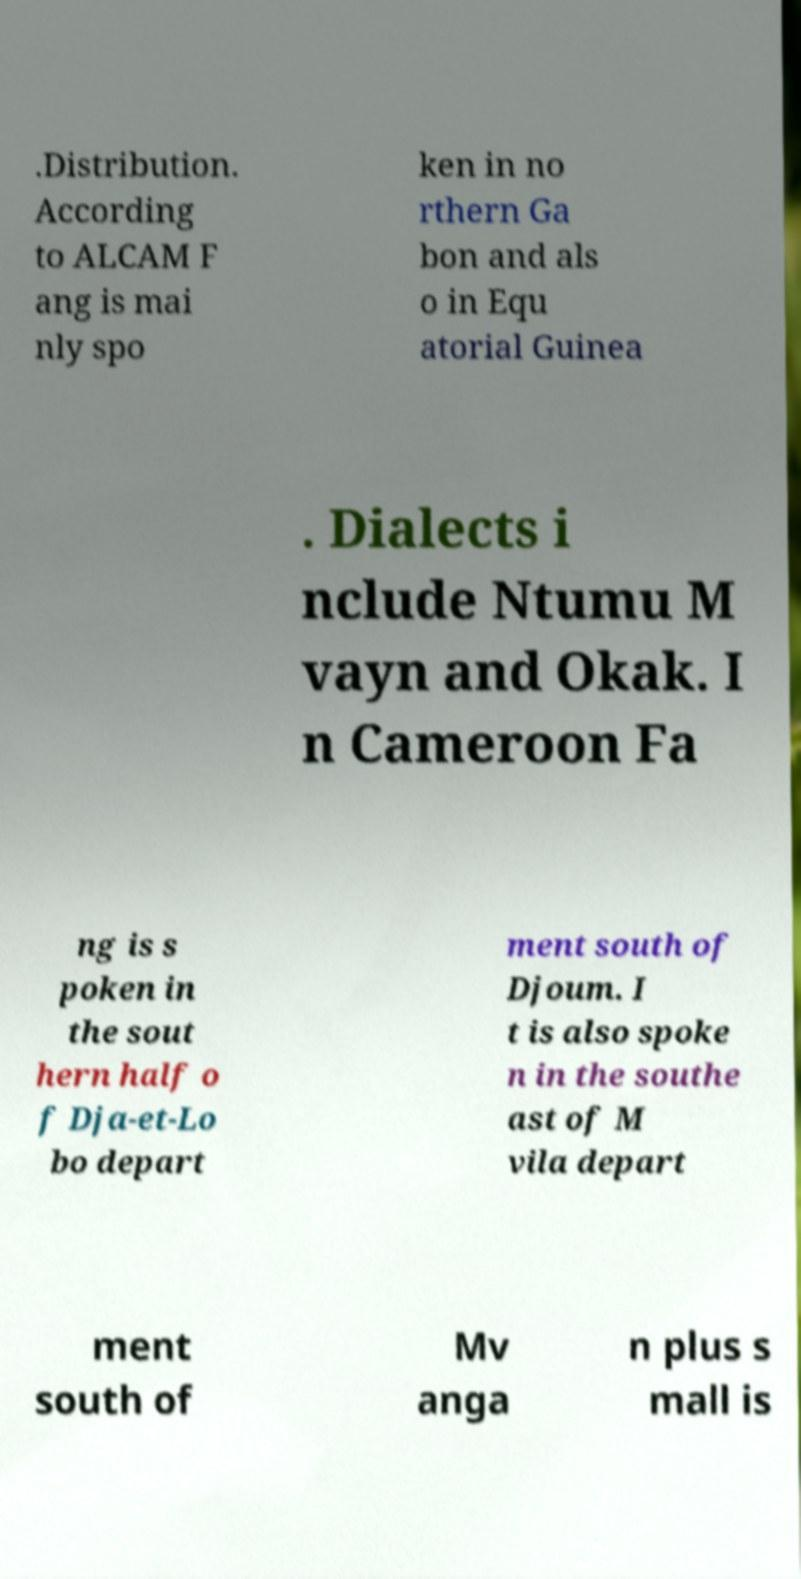Please read and relay the text visible in this image. What does it say? .Distribution. According to ALCAM F ang is mai nly spo ken in no rthern Ga bon and als o in Equ atorial Guinea . Dialects i nclude Ntumu M vayn and Okak. I n Cameroon Fa ng is s poken in the sout hern half o f Dja-et-Lo bo depart ment south of Djoum. I t is also spoke n in the southe ast of M vila depart ment south of Mv anga n plus s mall is 